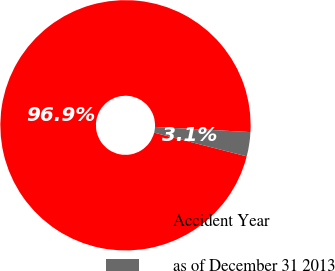Convert chart to OTSL. <chart><loc_0><loc_0><loc_500><loc_500><pie_chart><fcel>Accident Year<fcel>as of December 31 2013<nl><fcel>96.87%<fcel>3.13%<nl></chart> 